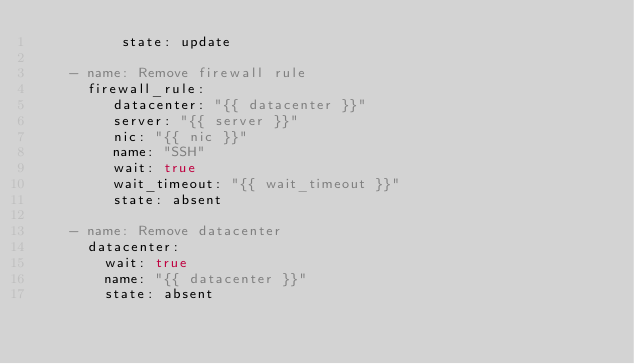Convert code to text. <code><loc_0><loc_0><loc_500><loc_500><_YAML_>          state: update

    - name: Remove firewall rule
      firewall_rule:
         datacenter: "{{ datacenter }}"
         server: "{{ server }}"
         nic: "{{ nic }}"
         name: "SSH"
         wait: true
         wait_timeout: "{{ wait_timeout }}"
         state: absent

    - name: Remove datacenter
      datacenter:
        wait: true
        name: "{{ datacenter }}"
        state: absent
</code> 